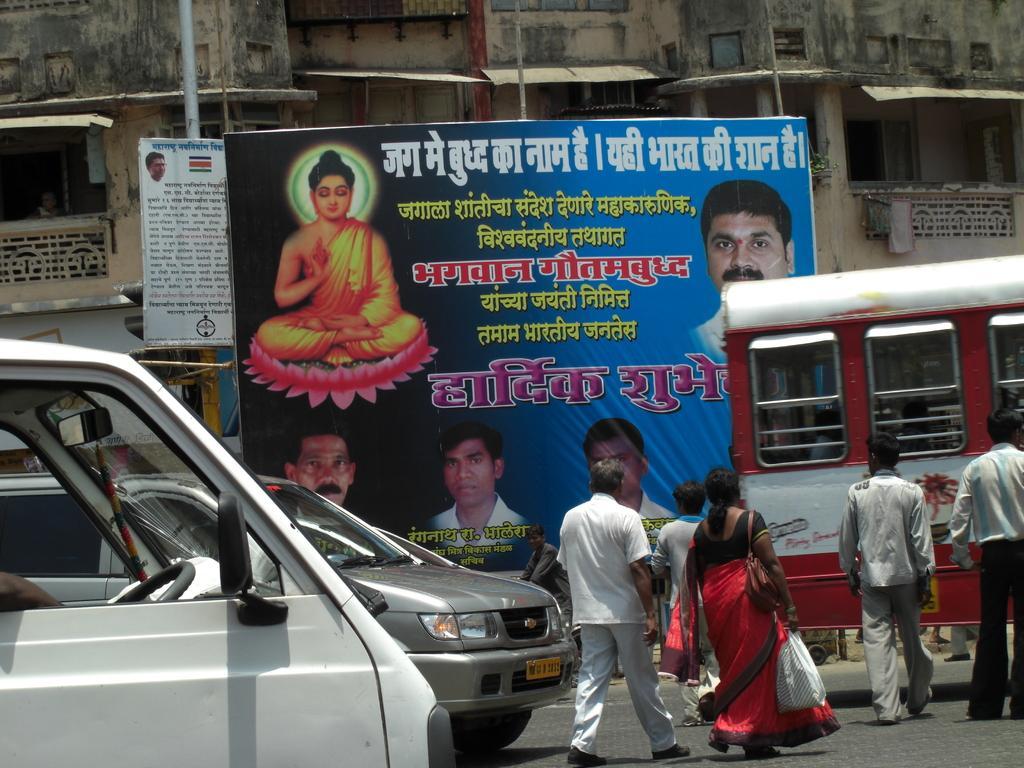Could you give a brief overview of what you see in this image? In this image there are vehicles on a road, and people are walking on a road, in the background there is a banner, on that banner there are some pictures and text and there is a building. 